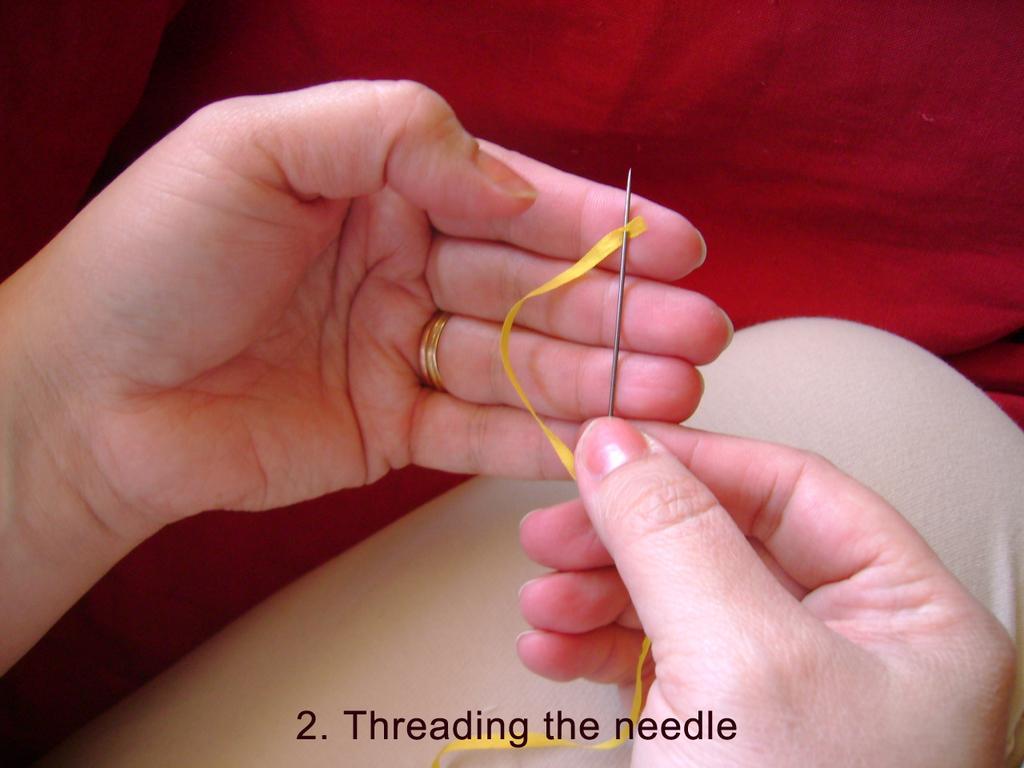How would you summarize this image in a sentence or two? In this picture there is a person threading the needle. At the top of there is a red color cloth. At the bottom there is text. 